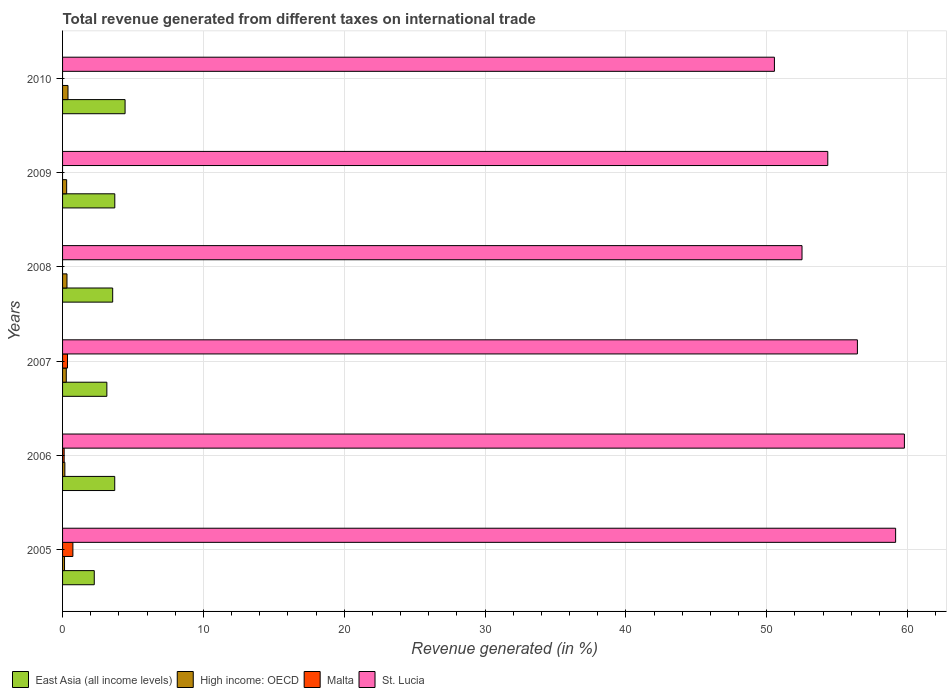How many groups of bars are there?
Offer a very short reply. 6. How many bars are there on the 5th tick from the top?
Offer a very short reply. 4. How many bars are there on the 5th tick from the bottom?
Your response must be concise. 3. What is the total revenue generated in East Asia (all income levels) in 2010?
Make the answer very short. 4.44. Across all years, what is the maximum total revenue generated in Malta?
Your response must be concise. 0.73. What is the total total revenue generated in Malta in the graph?
Give a very brief answer. 1.2. What is the difference between the total revenue generated in East Asia (all income levels) in 2007 and that in 2008?
Your answer should be very brief. -0.41. What is the difference between the total revenue generated in Malta in 2006 and the total revenue generated in High income: OECD in 2008?
Ensure brevity in your answer.  -0.2. What is the average total revenue generated in East Asia (all income levels) per year?
Your answer should be very brief. 3.47. In the year 2006, what is the difference between the total revenue generated in East Asia (all income levels) and total revenue generated in High income: OECD?
Provide a succinct answer. 3.54. What is the ratio of the total revenue generated in High income: OECD in 2005 to that in 2008?
Give a very brief answer. 0.45. Is the total revenue generated in East Asia (all income levels) in 2006 less than that in 2008?
Your answer should be very brief. No. Is the difference between the total revenue generated in East Asia (all income levels) in 2008 and 2010 greater than the difference between the total revenue generated in High income: OECD in 2008 and 2010?
Offer a terse response. No. What is the difference between the highest and the second highest total revenue generated in St. Lucia?
Give a very brief answer. 0.62. What is the difference between the highest and the lowest total revenue generated in High income: OECD?
Give a very brief answer. 0.25. Is it the case that in every year, the sum of the total revenue generated in High income: OECD and total revenue generated in St. Lucia is greater than the sum of total revenue generated in Malta and total revenue generated in East Asia (all income levels)?
Offer a very short reply. Yes. Is it the case that in every year, the sum of the total revenue generated in East Asia (all income levels) and total revenue generated in High income: OECD is greater than the total revenue generated in Malta?
Keep it short and to the point. Yes. How many bars are there?
Offer a very short reply. 21. What is the difference between two consecutive major ticks on the X-axis?
Offer a very short reply. 10. Does the graph contain any zero values?
Provide a short and direct response. Yes. Where does the legend appear in the graph?
Keep it short and to the point. Bottom left. What is the title of the graph?
Offer a very short reply. Total revenue generated from different taxes on international trade. What is the label or title of the X-axis?
Give a very brief answer. Revenue generated (in %). What is the Revenue generated (in %) of East Asia (all income levels) in 2005?
Keep it short and to the point. 2.25. What is the Revenue generated (in %) of High income: OECD in 2005?
Ensure brevity in your answer.  0.14. What is the Revenue generated (in %) of Malta in 2005?
Your answer should be very brief. 0.73. What is the Revenue generated (in %) of St. Lucia in 2005?
Keep it short and to the point. 59.15. What is the Revenue generated (in %) in East Asia (all income levels) in 2006?
Offer a very short reply. 3.7. What is the Revenue generated (in %) of High income: OECD in 2006?
Provide a short and direct response. 0.16. What is the Revenue generated (in %) of Malta in 2006?
Your response must be concise. 0.11. What is the Revenue generated (in %) of St. Lucia in 2006?
Keep it short and to the point. 59.77. What is the Revenue generated (in %) in East Asia (all income levels) in 2007?
Make the answer very short. 3.14. What is the Revenue generated (in %) of High income: OECD in 2007?
Keep it short and to the point. 0.26. What is the Revenue generated (in %) of Malta in 2007?
Keep it short and to the point. 0.35. What is the Revenue generated (in %) of St. Lucia in 2007?
Ensure brevity in your answer.  56.43. What is the Revenue generated (in %) of East Asia (all income levels) in 2008?
Provide a short and direct response. 3.56. What is the Revenue generated (in %) of High income: OECD in 2008?
Provide a short and direct response. 0.31. What is the Revenue generated (in %) of Malta in 2008?
Your response must be concise. 0. What is the Revenue generated (in %) of St. Lucia in 2008?
Give a very brief answer. 52.5. What is the Revenue generated (in %) in East Asia (all income levels) in 2009?
Give a very brief answer. 3.71. What is the Revenue generated (in %) of High income: OECD in 2009?
Provide a short and direct response. 0.29. What is the Revenue generated (in %) of St. Lucia in 2009?
Ensure brevity in your answer.  54.33. What is the Revenue generated (in %) in East Asia (all income levels) in 2010?
Provide a succinct answer. 4.44. What is the Revenue generated (in %) of High income: OECD in 2010?
Make the answer very short. 0.39. What is the Revenue generated (in %) of St. Lucia in 2010?
Your answer should be very brief. 50.54. Across all years, what is the maximum Revenue generated (in %) in East Asia (all income levels)?
Provide a short and direct response. 4.44. Across all years, what is the maximum Revenue generated (in %) in High income: OECD?
Offer a terse response. 0.39. Across all years, what is the maximum Revenue generated (in %) in Malta?
Offer a very short reply. 0.73. Across all years, what is the maximum Revenue generated (in %) of St. Lucia?
Your answer should be very brief. 59.77. Across all years, what is the minimum Revenue generated (in %) in East Asia (all income levels)?
Provide a succinct answer. 2.25. Across all years, what is the minimum Revenue generated (in %) of High income: OECD?
Make the answer very short. 0.14. Across all years, what is the minimum Revenue generated (in %) in St. Lucia?
Make the answer very short. 50.54. What is the total Revenue generated (in %) of East Asia (all income levels) in the graph?
Your answer should be compact. 20.81. What is the total Revenue generated (in %) of High income: OECD in the graph?
Make the answer very short. 1.56. What is the total Revenue generated (in %) in Malta in the graph?
Make the answer very short. 1.2. What is the total Revenue generated (in %) in St. Lucia in the graph?
Offer a very short reply. 332.72. What is the difference between the Revenue generated (in %) of East Asia (all income levels) in 2005 and that in 2006?
Your answer should be very brief. -1.45. What is the difference between the Revenue generated (in %) in High income: OECD in 2005 and that in 2006?
Your response must be concise. -0.02. What is the difference between the Revenue generated (in %) in Malta in 2005 and that in 2006?
Keep it short and to the point. 0.62. What is the difference between the Revenue generated (in %) in St. Lucia in 2005 and that in 2006?
Your response must be concise. -0.62. What is the difference between the Revenue generated (in %) in East Asia (all income levels) in 2005 and that in 2007?
Provide a short and direct response. -0.89. What is the difference between the Revenue generated (in %) in High income: OECD in 2005 and that in 2007?
Provide a short and direct response. -0.12. What is the difference between the Revenue generated (in %) in Malta in 2005 and that in 2007?
Provide a short and direct response. 0.38. What is the difference between the Revenue generated (in %) in St. Lucia in 2005 and that in 2007?
Ensure brevity in your answer.  2.71. What is the difference between the Revenue generated (in %) in East Asia (all income levels) in 2005 and that in 2008?
Keep it short and to the point. -1.31. What is the difference between the Revenue generated (in %) of High income: OECD in 2005 and that in 2008?
Make the answer very short. -0.17. What is the difference between the Revenue generated (in %) in St. Lucia in 2005 and that in 2008?
Ensure brevity in your answer.  6.65. What is the difference between the Revenue generated (in %) of East Asia (all income levels) in 2005 and that in 2009?
Make the answer very short. -1.46. What is the difference between the Revenue generated (in %) in High income: OECD in 2005 and that in 2009?
Ensure brevity in your answer.  -0.15. What is the difference between the Revenue generated (in %) of St. Lucia in 2005 and that in 2009?
Give a very brief answer. 4.82. What is the difference between the Revenue generated (in %) in East Asia (all income levels) in 2005 and that in 2010?
Offer a terse response. -2.19. What is the difference between the Revenue generated (in %) of High income: OECD in 2005 and that in 2010?
Keep it short and to the point. -0.25. What is the difference between the Revenue generated (in %) in St. Lucia in 2005 and that in 2010?
Offer a very short reply. 8.61. What is the difference between the Revenue generated (in %) in East Asia (all income levels) in 2006 and that in 2007?
Make the answer very short. 0.56. What is the difference between the Revenue generated (in %) of High income: OECD in 2006 and that in 2007?
Offer a terse response. -0.1. What is the difference between the Revenue generated (in %) of Malta in 2006 and that in 2007?
Make the answer very short. -0.24. What is the difference between the Revenue generated (in %) of St. Lucia in 2006 and that in 2007?
Offer a terse response. 3.34. What is the difference between the Revenue generated (in %) of East Asia (all income levels) in 2006 and that in 2008?
Offer a terse response. 0.15. What is the difference between the Revenue generated (in %) in High income: OECD in 2006 and that in 2008?
Keep it short and to the point. -0.15. What is the difference between the Revenue generated (in %) in St. Lucia in 2006 and that in 2008?
Your response must be concise. 7.27. What is the difference between the Revenue generated (in %) in East Asia (all income levels) in 2006 and that in 2009?
Your response must be concise. -0. What is the difference between the Revenue generated (in %) in High income: OECD in 2006 and that in 2009?
Give a very brief answer. -0.13. What is the difference between the Revenue generated (in %) in St. Lucia in 2006 and that in 2009?
Offer a terse response. 5.44. What is the difference between the Revenue generated (in %) of East Asia (all income levels) in 2006 and that in 2010?
Offer a terse response. -0.73. What is the difference between the Revenue generated (in %) of High income: OECD in 2006 and that in 2010?
Make the answer very short. -0.22. What is the difference between the Revenue generated (in %) of St. Lucia in 2006 and that in 2010?
Offer a terse response. 9.23. What is the difference between the Revenue generated (in %) in East Asia (all income levels) in 2007 and that in 2008?
Keep it short and to the point. -0.41. What is the difference between the Revenue generated (in %) in High income: OECD in 2007 and that in 2008?
Ensure brevity in your answer.  -0.05. What is the difference between the Revenue generated (in %) in St. Lucia in 2007 and that in 2008?
Provide a succinct answer. 3.93. What is the difference between the Revenue generated (in %) in East Asia (all income levels) in 2007 and that in 2009?
Your answer should be very brief. -0.56. What is the difference between the Revenue generated (in %) in High income: OECD in 2007 and that in 2009?
Ensure brevity in your answer.  -0.03. What is the difference between the Revenue generated (in %) of St. Lucia in 2007 and that in 2009?
Offer a very short reply. 2.1. What is the difference between the Revenue generated (in %) in East Asia (all income levels) in 2007 and that in 2010?
Keep it short and to the point. -1.29. What is the difference between the Revenue generated (in %) of High income: OECD in 2007 and that in 2010?
Your answer should be very brief. -0.12. What is the difference between the Revenue generated (in %) in St. Lucia in 2007 and that in 2010?
Your answer should be compact. 5.89. What is the difference between the Revenue generated (in %) of East Asia (all income levels) in 2008 and that in 2009?
Give a very brief answer. -0.15. What is the difference between the Revenue generated (in %) of High income: OECD in 2008 and that in 2009?
Keep it short and to the point. 0.02. What is the difference between the Revenue generated (in %) of St. Lucia in 2008 and that in 2009?
Keep it short and to the point. -1.83. What is the difference between the Revenue generated (in %) of East Asia (all income levels) in 2008 and that in 2010?
Provide a short and direct response. -0.88. What is the difference between the Revenue generated (in %) of High income: OECD in 2008 and that in 2010?
Make the answer very short. -0.07. What is the difference between the Revenue generated (in %) of St. Lucia in 2008 and that in 2010?
Your response must be concise. 1.96. What is the difference between the Revenue generated (in %) of East Asia (all income levels) in 2009 and that in 2010?
Give a very brief answer. -0.73. What is the difference between the Revenue generated (in %) in High income: OECD in 2009 and that in 2010?
Your answer should be very brief. -0.1. What is the difference between the Revenue generated (in %) in St. Lucia in 2009 and that in 2010?
Offer a terse response. 3.79. What is the difference between the Revenue generated (in %) in East Asia (all income levels) in 2005 and the Revenue generated (in %) in High income: OECD in 2006?
Give a very brief answer. 2.09. What is the difference between the Revenue generated (in %) in East Asia (all income levels) in 2005 and the Revenue generated (in %) in Malta in 2006?
Provide a succinct answer. 2.14. What is the difference between the Revenue generated (in %) of East Asia (all income levels) in 2005 and the Revenue generated (in %) of St. Lucia in 2006?
Provide a short and direct response. -57.52. What is the difference between the Revenue generated (in %) in High income: OECD in 2005 and the Revenue generated (in %) in Malta in 2006?
Your answer should be very brief. 0.03. What is the difference between the Revenue generated (in %) of High income: OECD in 2005 and the Revenue generated (in %) of St. Lucia in 2006?
Make the answer very short. -59.63. What is the difference between the Revenue generated (in %) of Malta in 2005 and the Revenue generated (in %) of St. Lucia in 2006?
Make the answer very short. -59.04. What is the difference between the Revenue generated (in %) of East Asia (all income levels) in 2005 and the Revenue generated (in %) of High income: OECD in 2007?
Your answer should be compact. 1.99. What is the difference between the Revenue generated (in %) of East Asia (all income levels) in 2005 and the Revenue generated (in %) of Malta in 2007?
Offer a very short reply. 1.9. What is the difference between the Revenue generated (in %) in East Asia (all income levels) in 2005 and the Revenue generated (in %) in St. Lucia in 2007?
Keep it short and to the point. -54.18. What is the difference between the Revenue generated (in %) of High income: OECD in 2005 and the Revenue generated (in %) of Malta in 2007?
Your response must be concise. -0.21. What is the difference between the Revenue generated (in %) of High income: OECD in 2005 and the Revenue generated (in %) of St. Lucia in 2007?
Ensure brevity in your answer.  -56.29. What is the difference between the Revenue generated (in %) in Malta in 2005 and the Revenue generated (in %) in St. Lucia in 2007?
Give a very brief answer. -55.7. What is the difference between the Revenue generated (in %) of East Asia (all income levels) in 2005 and the Revenue generated (in %) of High income: OECD in 2008?
Keep it short and to the point. 1.94. What is the difference between the Revenue generated (in %) in East Asia (all income levels) in 2005 and the Revenue generated (in %) in St. Lucia in 2008?
Offer a terse response. -50.25. What is the difference between the Revenue generated (in %) in High income: OECD in 2005 and the Revenue generated (in %) in St. Lucia in 2008?
Ensure brevity in your answer.  -52.36. What is the difference between the Revenue generated (in %) in Malta in 2005 and the Revenue generated (in %) in St. Lucia in 2008?
Provide a succinct answer. -51.77. What is the difference between the Revenue generated (in %) in East Asia (all income levels) in 2005 and the Revenue generated (in %) in High income: OECD in 2009?
Offer a very short reply. 1.96. What is the difference between the Revenue generated (in %) in East Asia (all income levels) in 2005 and the Revenue generated (in %) in St. Lucia in 2009?
Keep it short and to the point. -52.08. What is the difference between the Revenue generated (in %) of High income: OECD in 2005 and the Revenue generated (in %) of St. Lucia in 2009?
Make the answer very short. -54.19. What is the difference between the Revenue generated (in %) in Malta in 2005 and the Revenue generated (in %) in St. Lucia in 2009?
Give a very brief answer. -53.6. What is the difference between the Revenue generated (in %) of East Asia (all income levels) in 2005 and the Revenue generated (in %) of High income: OECD in 2010?
Give a very brief answer. 1.86. What is the difference between the Revenue generated (in %) in East Asia (all income levels) in 2005 and the Revenue generated (in %) in St. Lucia in 2010?
Keep it short and to the point. -48.29. What is the difference between the Revenue generated (in %) of High income: OECD in 2005 and the Revenue generated (in %) of St. Lucia in 2010?
Provide a succinct answer. -50.4. What is the difference between the Revenue generated (in %) of Malta in 2005 and the Revenue generated (in %) of St. Lucia in 2010?
Keep it short and to the point. -49.81. What is the difference between the Revenue generated (in %) of East Asia (all income levels) in 2006 and the Revenue generated (in %) of High income: OECD in 2007?
Your answer should be compact. 3.44. What is the difference between the Revenue generated (in %) in East Asia (all income levels) in 2006 and the Revenue generated (in %) in Malta in 2007?
Provide a short and direct response. 3.35. What is the difference between the Revenue generated (in %) of East Asia (all income levels) in 2006 and the Revenue generated (in %) of St. Lucia in 2007?
Ensure brevity in your answer.  -52.73. What is the difference between the Revenue generated (in %) in High income: OECD in 2006 and the Revenue generated (in %) in Malta in 2007?
Your response must be concise. -0.19. What is the difference between the Revenue generated (in %) in High income: OECD in 2006 and the Revenue generated (in %) in St. Lucia in 2007?
Make the answer very short. -56.27. What is the difference between the Revenue generated (in %) in Malta in 2006 and the Revenue generated (in %) in St. Lucia in 2007?
Provide a succinct answer. -56.32. What is the difference between the Revenue generated (in %) in East Asia (all income levels) in 2006 and the Revenue generated (in %) in High income: OECD in 2008?
Provide a short and direct response. 3.39. What is the difference between the Revenue generated (in %) in East Asia (all income levels) in 2006 and the Revenue generated (in %) in St. Lucia in 2008?
Your response must be concise. -48.8. What is the difference between the Revenue generated (in %) of High income: OECD in 2006 and the Revenue generated (in %) of St. Lucia in 2008?
Give a very brief answer. -52.34. What is the difference between the Revenue generated (in %) in Malta in 2006 and the Revenue generated (in %) in St. Lucia in 2008?
Provide a short and direct response. -52.39. What is the difference between the Revenue generated (in %) of East Asia (all income levels) in 2006 and the Revenue generated (in %) of High income: OECD in 2009?
Give a very brief answer. 3.41. What is the difference between the Revenue generated (in %) of East Asia (all income levels) in 2006 and the Revenue generated (in %) of St. Lucia in 2009?
Ensure brevity in your answer.  -50.63. What is the difference between the Revenue generated (in %) of High income: OECD in 2006 and the Revenue generated (in %) of St. Lucia in 2009?
Give a very brief answer. -54.17. What is the difference between the Revenue generated (in %) of Malta in 2006 and the Revenue generated (in %) of St. Lucia in 2009?
Your response must be concise. -54.22. What is the difference between the Revenue generated (in %) of East Asia (all income levels) in 2006 and the Revenue generated (in %) of High income: OECD in 2010?
Offer a terse response. 3.32. What is the difference between the Revenue generated (in %) of East Asia (all income levels) in 2006 and the Revenue generated (in %) of St. Lucia in 2010?
Your answer should be very brief. -46.84. What is the difference between the Revenue generated (in %) in High income: OECD in 2006 and the Revenue generated (in %) in St. Lucia in 2010?
Keep it short and to the point. -50.38. What is the difference between the Revenue generated (in %) in Malta in 2006 and the Revenue generated (in %) in St. Lucia in 2010?
Keep it short and to the point. -50.43. What is the difference between the Revenue generated (in %) in East Asia (all income levels) in 2007 and the Revenue generated (in %) in High income: OECD in 2008?
Provide a short and direct response. 2.83. What is the difference between the Revenue generated (in %) in East Asia (all income levels) in 2007 and the Revenue generated (in %) in St. Lucia in 2008?
Keep it short and to the point. -49.36. What is the difference between the Revenue generated (in %) in High income: OECD in 2007 and the Revenue generated (in %) in St. Lucia in 2008?
Your response must be concise. -52.24. What is the difference between the Revenue generated (in %) of Malta in 2007 and the Revenue generated (in %) of St. Lucia in 2008?
Offer a very short reply. -52.15. What is the difference between the Revenue generated (in %) of East Asia (all income levels) in 2007 and the Revenue generated (in %) of High income: OECD in 2009?
Your response must be concise. 2.85. What is the difference between the Revenue generated (in %) in East Asia (all income levels) in 2007 and the Revenue generated (in %) in St. Lucia in 2009?
Offer a very short reply. -51.19. What is the difference between the Revenue generated (in %) in High income: OECD in 2007 and the Revenue generated (in %) in St. Lucia in 2009?
Keep it short and to the point. -54.07. What is the difference between the Revenue generated (in %) in Malta in 2007 and the Revenue generated (in %) in St. Lucia in 2009?
Make the answer very short. -53.98. What is the difference between the Revenue generated (in %) of East Asia (all income levels) in 2007 and the Revenue generated (in %) of High income: OECD in 2010?
Ensure brevity in your answer.  2.76. What is the difference between the Revenue generated (in %) of East Asia (all income levels) in 2007 and the Revenue generated (in %) of St. Lucia in 2010?
Make the answer very short. -47.4. What is the difference between the Revenue generated (in %) in High income: OECD in 2007 and the Revenue generated (in %) in St. Lucia in 2010?
Keep it short and to the point. -50.28. What is the difference between the Revenue generated (in %) in Malta in 2007 and the Revenue generated (in %) in St. Lucia in 2010?
Provide a short and direct response. -50.19. What is the difference between the Revenue generated (in %) of East Asia (all income levels) in 2008 and the Revenue generated (in %) of High income: OECD in 2009?
Make the answer very short. 3.27. What is the difference between the Revenue generated (in %) of East Asia (all income levels) in 2008 and the Revenue generated (in %) of St. Lucia in 2009?
Give a very brief answer. -50.77. What is the difference between the Revenue generated (in %) of High income: OECD in 2008 and the Revenue generated (in %) of St. Lucia in 2009?
Keep it short and to the point. -54.02. What is the difference between the Revenue generated (in %) of East Asia (all income levels) in 2008 and the Revenue generated (in %) of High income: OECD in 2010?
Give a very brief answer. 3.17. What is the difference between the Revenue generated (in %) in East Asia (all income levels) in 2008 and the Revenue generated (in %) in St. Lucia in 2010?
Offer a very short reply. -46.98. What is the difference between the Revenue generated (in %) in High income: OECD in 2008 and the Revenue generated (in %) in St. Lucia in 2010?
Make the answer very short. -50.23. What is the difference between the Revenue generated (in %) in East Asia (all income levels) in 2009 and the Revenue generated (in %) in High income: OECD in 2010?
Offer a terse response. 3.32. What is the difference between the Revenue generated (in %) of East Asia (all income levels) in 2009 and the Revenue generated (in %) of St. Lucia in 2010?
Provide a succinct answer. -46.83. What is the difference between the Revenue generated (in %) in High income: OECD in 2009 and the Revenue generated (in %) in St. Lucia in 2010?
Give a very brief answer. -50.25. What is the average Revenue generated (in %) in East Asia (all income levels) per year?
Offer a terse response. 3.47. What is the average Revenue generated (in %) in High income: OECD per year?
Your answer should be very brief. 0.26. What is the average Revenue generated (in %) of Malta per year?
Your answer should be compact. 0.2. What is the average Revenue generated (in %) in St. Lucia per year?
Offer a very short reply. 55.45. In the year 2005, what is the difference between the Revenue generated (in %) in East Asia (all income levels) and Revenue generated (in %) in High income: OECD?
Make the answer very short. 2.11. In the year 2005, what is the difference between the Revenue generated (in %) of East Asia (all income levels) and Revenue generated (in %) of Malta?
Offer a terse response. 1.52. In the year 2005, what is the difference between the Revenue generated (in %) in East Asia (all income levels) and Revenue generated (in %) in St. Lucia?
Provide a short and direct response. -56.9. In the year 2005, what is the difference between the Revenue generated (in %) of High income: OECD and Revenue generated (in %) of Malta?
Give a very brief answer. -0.59. In the year 2005, what is the difference between the Revenue generated (in %) of High income: OECD and Revenue generated (in %) of St. Lucia?
Make the answer very short. -59.01. In the year 2005, what is the difference between the Revenue generated (in %) of Malta and Revenue generated (in %) of St. Lucia?
Keep it short and to the point. -58.41. In the year 2006, what is the difference between the Revenue generated (in %) in East Asia (all income levels) and Revenue generated (in %) in High income: OECD?
Offer a very short reply. 3.54. In the year 2006, what is the difference between the Revenue generated (in %) of East Asia (all income levels) and Revenue generated (in %) of Malta?
Make the answer very short. 3.59. In the year 2006, what is the difference between the Revenue generated (in %) in East Asia (all income levels) and Revenue generated (in %) in St. Lucia?
Your response must be concise. -56.07. In the year 2006, what is the difference between the Revenue generated (in %) in High income: OECD and Revenue generated (in %) in Malta?
Your answer should be compact. 0.05. In the year 2006, what is the difference between the Revenue generated (in %) of High income: OECD and Revenue generated (in %) of St. Lucia?
Offer a terse response. -59.61. In the year 2006, what is the difference between the Revenue generated (in %) in Malta and Revenue generated (in %) in St. Lucia?
Your response must be concise. -59.66. In the year 2007, what is the difference between the Revenue generated (in %) in East Asia (all income levels) and Revenue generated (in %) in High income: OECD?
Keep it short and to the point. 2.88. In the year 2007, what is the difference between the Revenue generated (in %) of East Asia (all income levels) and Revenue generated (in %) of Malta?
Your answer should be very brief. 2.79. In the year 2007, what is the difference between the Revenue generated (in %) in East Asia (all income levels) and Revenue generated (in %) in St. Lucia?
Provide a short and direct response. -53.29. In the year 2007, what is the difference between the Revenue generated (in %) of High income: OECD and Revenue generated (in %) of Malta?
Provide a short and direct response. -0.09. In the year 2007, what is the difference between the Revenue generated (in %) in High income: OECD and Revenue generated (in %) in St. Lucia?
Provide a short and direct response. -56.17. In the year 2007, what is the difference between the Revenue generated (in %) of Malta and Revenue generated (in %) of St. Lucia?
Give a very brief answer. -56.08. In the year 2008, what is the difference between the Revenue generated (in %) of East Asia (all income levels) and Revenue generated (in %) of High income: OECD?
Your response must be concise. 3.24. In the year 2008, what is the difference between the Revenue generated (in %) of East Asia (all income levels) and Revenue generated (in %) of St. Lucia?
Offer a terse response. -48.94. In the year 2008, what is the difference between the Revenue generated (in %) in High income: OECD and Revenue generated (in %) in St. Lucia?
Keep it short and to the point. -52.19. In the year 2009, what is the difference between the Revenue generated (in %) in East Asia (all income levels) and Revenue generated (in %) in High income: OECD?
Make the answer very short. 3.42. In the year 2009, what is the difference between the Revenue generated (in %) of East Asia (all income levels) and Revenue generated (in %) of St. Lucia?
Provide a succinct answer. -50.62. In the year 2009, what is the difference between the Revenue generated (in %) in High income: OECD and Revenue generated (in %) in St. Lucia?
Your answer should be compact. -54.04. In the year 2010, what is the difference between the Revenue generated (in %) in East Asia (all income levels) and Revenue generated (in %) in High income: OECD?
Make the answer very short. 4.05. In the year 2010, what is the difference between the Revenue generated (in %) of East Asia (all income levels) and Revenue generated (in %) of St. Lucia?
Provide a succinct answer. -46.1. In the year 2010, what is the difference between the Revenue generated (in %) in High income: OECD and Revenue generated (in %) in St. Lucia?
Give a very brief answer. -50.16. What is the ratio of the Revenue generated (in %) of East Asia (all income levels) in 2005 to that in 2006?
Your answer should be compact. 0.61. What is the ratio of the Revenue generated (in %) of High income: OECD in 2005 to that in 2006?
Keep it short and to the point. 0.86. What is the ratio of the Revenue generated (in %) of Malta in 2005 to that in 2006?
Keep it short and to the point. 6.46. What is the ratio of the Revenue generated (in %) of East Asia (all income levels) in 2005 to that in 2007?
Offer a very short reply. 0.72. What is the ratio of the Revenue generated (in %) in High income: OECD in 2005 to that in 2007?
Your response must be concise. 0.53. What is the ratio of the Revenue generated (in %) of Malta in 2005 to that in 2007?
Offer a terse response. 2.09. What is the ratio of the Revenue generated (in %) of St. Lucia in 2005 to that in 2007?
Provide a short and direct response. 1.05. What is the ratio of the Revenue generated (in %) in East Asia (all income levels) in 2005 to that in 2008?
Ensure brevity in your answer.  0.63. What is the ratio of the Revenue generated (in %) in High income: OECD in 2005 to that in 2008?
Offer a terse response. 0.45. What is the ratio of the Revenue generated (in %) of St. Lucia in 2005 to that in 2008?
Make the answer very short. 1.13. What is the ratio of the Revenue generated (in %) of East Asia (all income levels) in 2005 to that in 2009?
Make the answer very short. 0.61. What is the ratio of the Revenue generated (in %) of High income: OECD in 2005 to that in 2009?
Offer a terse response. 0.48. What is the ratio of the Revenue generated (in %) in St. Lucia in 2005 to that in 2009?
Keep it short and to the point. 1.09. What is the ratio of the Revenue generated (in %) in East Asia (all income levels) in 2005 to that in 2010?
Ensure brevity in your answer.  0.51. What is the ratio of the Revenue generated (in %) in High income: OECD in 2005 to that in 2010?
Keep it short and to the point. 0.36. What is the ratio of the Revenue generated (in %) in St. Lucia in 2005 to that in 2010?
Offer a terse response. 1.17. What is the ratio of the Revenue generated (in %) in East Asia (all income levels) in 2006 to that in 2007?
Offer a terse response. 1.18. What is the ratio of the Revenue generated (in %) in High income: OECD in 2006 to that in 2007?
Provide a succinct answer. 0.62. What is the ratio of the Revenue generated (in %) of Malta in 2006 to that in 2007?
Your response must be concise. 0.32. What is the ratio of the Revenue generated (in %) of St. Lucia in 2006 to that in 2007?
Your response must be concise. 1.06. What is the ratio of the Revenue generated (in %) in East Asia (all income levels) in 2006 to that in 2008?
Make the answer very short. 1.04. What is the ratio of the Revenue generated (in %) of High income: OECD in 2006 to that in 2008?
Your response must be concise. 0.52. What is the ratio of the Revenue generated (in %) of St. Lucia in 2006 to that in 2008?
Your answer should be very brief. 1.14. What is the ratio of the Revenue generated (in %) in East Asia (all income levels) in 2006 to that in 2009?
Provide a short and direct response. 1. What is the ratio of the Revenue generated (in %) of High income: OECD in 2006 to that in 2009?
Your answer should be very brief. 0.56. What is the ratio of the Revenue generated (in %) in St. Lucia in 2006 to that in 2009?
Ensure brevity in your answer.  1.1. What is the ratio of the Revenue generated (in %) of East Asia (all income levels) in 2006 to that in 2010?
Your response must be concise. 0.83. What is the ratio of the Revenue generated (in %) of High income: OECD in 2006 to that in 2010?
Provide a succinct answer. 0.42. What is the ratio of the Revenue generated (in %) of St. Lucia in 2006 to that in 2010?
Ensure brevity in your answer.  1.18. What is the ratio of the Revenue generated (in %) of East Asia (all income levels) in 2007 to that in 2008?
Make the answer very short. 0.88. What is the ratio of the Revenue generated (in %) in High income: OECD in 2007 to that in 2008?
Make the answer very short. 0.84. What is the ratio of the Revenue generated (in %) of St. Lucia in 2007 to that in 2008?
Keep it short and to the point. 1.07. What is the ratio of the Revenue generated (in %) in East Asia (all income levels) in 2007 to that in 2009?
Keep it short and to the point. 0.85. What is the ratio of the Revenue generated (in %) of High income: OECD in 2007 to that in 2009?
Give a very brief answer. 0.91. What is the ratio of the Revenue generated (in %) in St. Lucia in 2007 to that in 2009?
Ensure brevity in your answer.  1.04. What is the ratio of the Revenue generated (in %) in East Asia (all income levels) in 2007 to that in 2010?
Offer a terse response. 0.71. What is the ratio of the Revenue generated (in %) in High income: OECD in 2007 to that in 2010?
Your answer should be very brief. 0.68. What is the ratio of the Revenue generated (in %) of St. Lucia in 2007 to that in 2010?
Your response must be concise. 1.12. What is the ratio of the Revenue generated (in %) in East Asia (all income levels) in 2008 to that in 2009?
Provide a succinct answer. 0.96. What is the ratio of the Revenue generated (in %) of High income: OECD in 2008 to that in 2009?
Ensure brevity in your answer.  1.08. What is the ratio of the Revenue generated (in %) of St. Lucia in 2008 to that in 2009?
Offer a very short reply. 0.97. What is the ratio of the Revenue generated (in %) of East Asia (all income levels) in 2008 to that in 2010?
Give a very brief answer. 0.8. What is the ratio of the Revenue generated (in %) of High income: OECD in 2008 to that in 2010?
Your response must be concise. 0.81. What is the ratio of the Revenue generated (in %) in St. Lucia in 2008 to that in 2010?
Give a very brief answer. 1.04. What is the ratio of the Revenue generated (in %) of East Asia (all income levels) in 2009 to that in 2010?
Offer a very short reply. 0.84. What is the ratio of the Revenue generated (in %) of High income: OECD in 2009 to that in 2010?
Offer a terse response. 0.75. What is the ratio of the Revenue generated (in %) of St. Lucia in 2009 to that in 2010?
Give a very brief answer. 1.07. What is the difference between the highest and the second highest Revenue generated (in %) of East Asia (all income levels)?
Offer a very short reply. 0.73. What is the difference between the highest and the second highest Revenue generated (in %) in High income: OECD?
Your answer should be very brief. 0.07. What is the difference between the highest and the second highest Revenue generated (in %) in Malta?
Provide a succinct answer. 0.38. What is the difference between the highest and the second highest Revenue generated (in %) in St. Lucia?
Provide a succinct answer. 0.62. What is the difference between the highest and the lowest Revenue generated (in %) of East Asia (all income levels)?
Offer a terse response. 2.19. What is the difference between the highest and the lowest Revenue generated (in %) in High income: OECD?
Offer a terse response. 0.25. What is the difference between the highest and the lowest Revenue generated (in %) of Malta?
Give a very brief answer. 0.73. What is the difference between the highest and the lowest Revenue generated (in %) in St. Lucia?
Offer a very short reply. 9.23. 